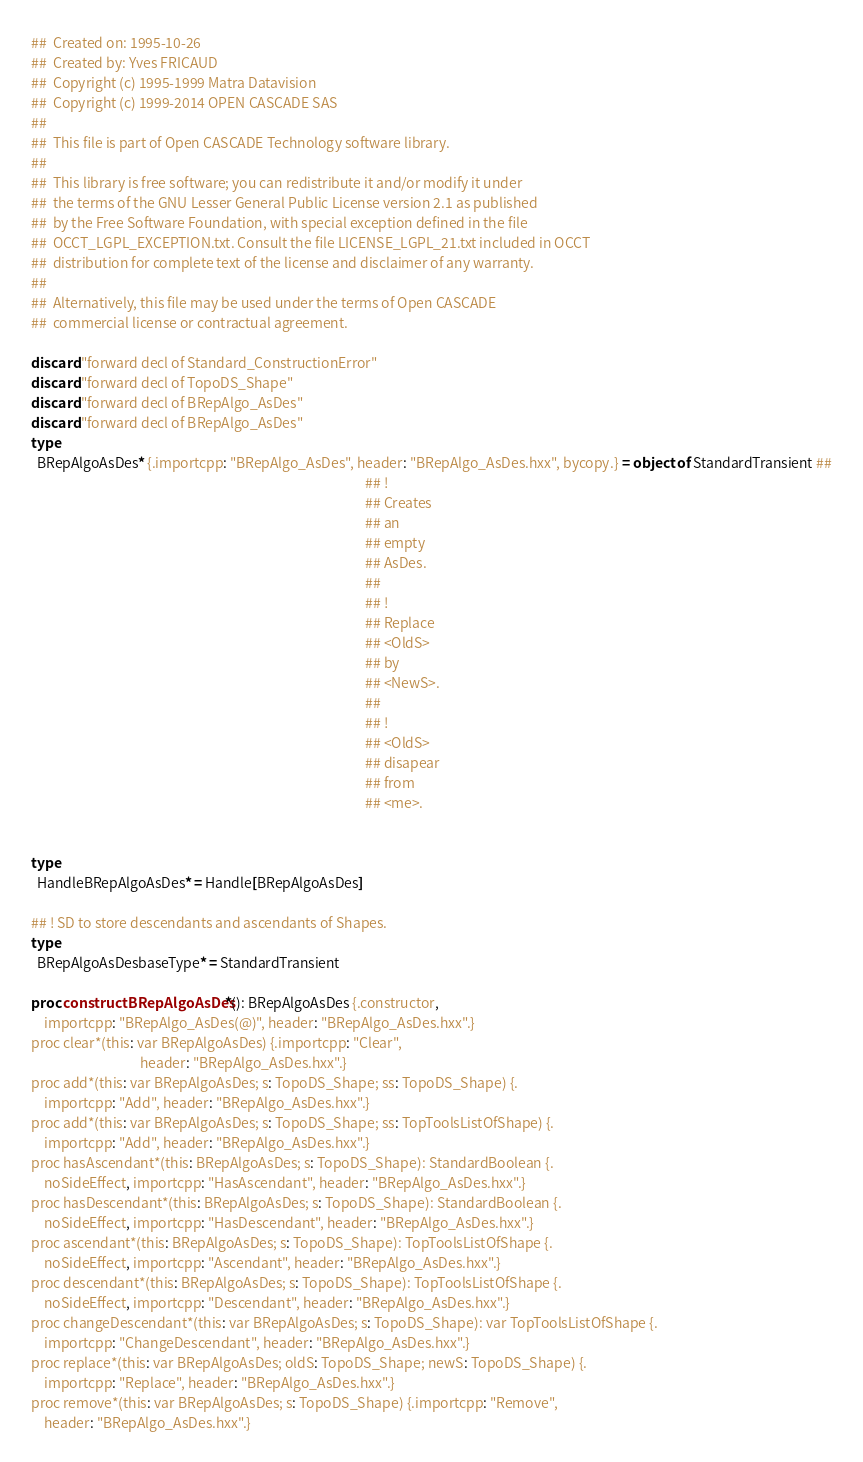Convert code to text. <code><loc_0><loc_0><loc_500><loc_500><_Nim_>##  Created on: 1995-10-26
##  Created by: Yves FRICAUD
##  Copyright (c) 1995-1999 Matra Datavision
##  Copyright (c) 1999-2014 OPEN CASCADE SAS
##
##  This file is part of Open CASCADE Technology software library.
##
##  This library is free software; you can redistribute it and/or modify it under
##  the terms of the GNU Lesser General Public License version 2.1 as published
##  by the Free Software Foundation, with special exception defined in the file
##  OCCT_LGPL_EXCEPTION.txt. Consult the file LICENSE_LGPL_21.txt included in OCCT
##  distribution for complete text of the license and disclaimer of any warranty.
##
##  Alternatively, this file may be used under the terms of Open CASCADE
##  commercial license or contractual agreement.

discard "forward decl of Standard_ConstructionError"
discard "forward decl of TopoDS_Shape"
discard "forward decl of BRepAlgo_AsDes"
discard "forward decl of BRepAlgo_AsDes"
type
  BRepAlgoAsDes* {.importcpp: "BRepAlgo_AsDes", header: "BRepAlgo_AsDes.hxx", bycopy.} = object of StandardTransient ##
                                                                                                           ## !
                                                                                                           ## Creates
                                                                                                           ## an
                                                                                                           ## empty
                                                                                                           ## AsDes.
                                                                                                           ##
                                                                                                           ## !
                                                                                                           ## Replace
                                                                                                           ## <OldS>
                                                                                                           ## by
                                                                                                           ## <NewS>.
                                                                                                           ##
                                                                                                           ## !
                                                                                                           ## <OldS>
                                                                                                           ## disapear
                                                                                                           ## from
                                                                                                           ## <me>.


type
  HandleBRepAlgoAsDes* = Handle[BRepAlgoAsDes]

## ! SD to store descendants and ascendants of Shapes.
type
  BRepAlgoAsDesbaseType* = StandardTransient

proc constructBRepAlgoAsDes*(): BRepAlgoAsDes {.constructor,
    importcpp: "BRepAlgo_AsDes(@)", header: "BRepAlgo_AsDes.hxx".}
proc clear*(this: var BRepAlgoAsDes) {.importcpp: "Clear",
                                   header: "BRepAlgo_AsDes.hxx".}
proc add*(this: var BRepAlgoAsDes; s: TopoDS_Shape; ss: TopoDS_Shape) {.
    importcpp: "Add", header: "BRepAlgo_AsDes.hxx".}
proc add*(this: var BRepAlgoAsDes; s: TopoDS_Shape; ss: TopToolsListOfShape) {.
    importcpp: "Add", header: "BRepAlgo_AsDes.hxx".}
proc hasAscendant*(this: BRepAlgoAsDes; s: TopoDS_Shape): StandardBoolean {.
    noSideEffect, importcpp: "HasAscendant", header: "BRepAlgo_AsDes.hxx".}
proc hasDescendant*(this: BRepAlgoAsDes; s: TopoDS_Shape): StandardBoolean {.
    noSideEffect, importcpp: "HasDescendant", header: "BRepAlgo_AsDes.hxx".}
proc ascendant*(this: BRepAlgoAsDes; s: TopoDS_Shape): TopToolsListOfShape {.
    noSideEffect, importcpp: "Ascendant", header: "BRepAlgo_AsDes.hxx".}
proc descendant*(this: BRepAlgoAsDes; s: TopoDS_Shape): TopToolsListOfShape {.
    noSideEffect, importcpp: "Descendant", header: "BRepAlgo_AsDes.hxx".}
proc changeDescendant*(this: var BRepAlgoAsDes; s: TopoDS_Shape): var TopToolsListOfShape {.
    importcpp: "ChangeDescendant", header: "BRepAlgo_AsDes.hxx".}
proc replace*(this: var BRepAlgoAsDes; oldS: TopoDS_Shape; newS: TopoDS_Shape) {.
    importcpp: "Replace", header: "BRepAlgo_AsDes.hxx".}
proc remove*(this: var BRepAlgoAsDes; s: TopoDS_Shape) {.importcpp: "Remove",
    header: "BRepAlgo_AsDes.hxx".}</code> 